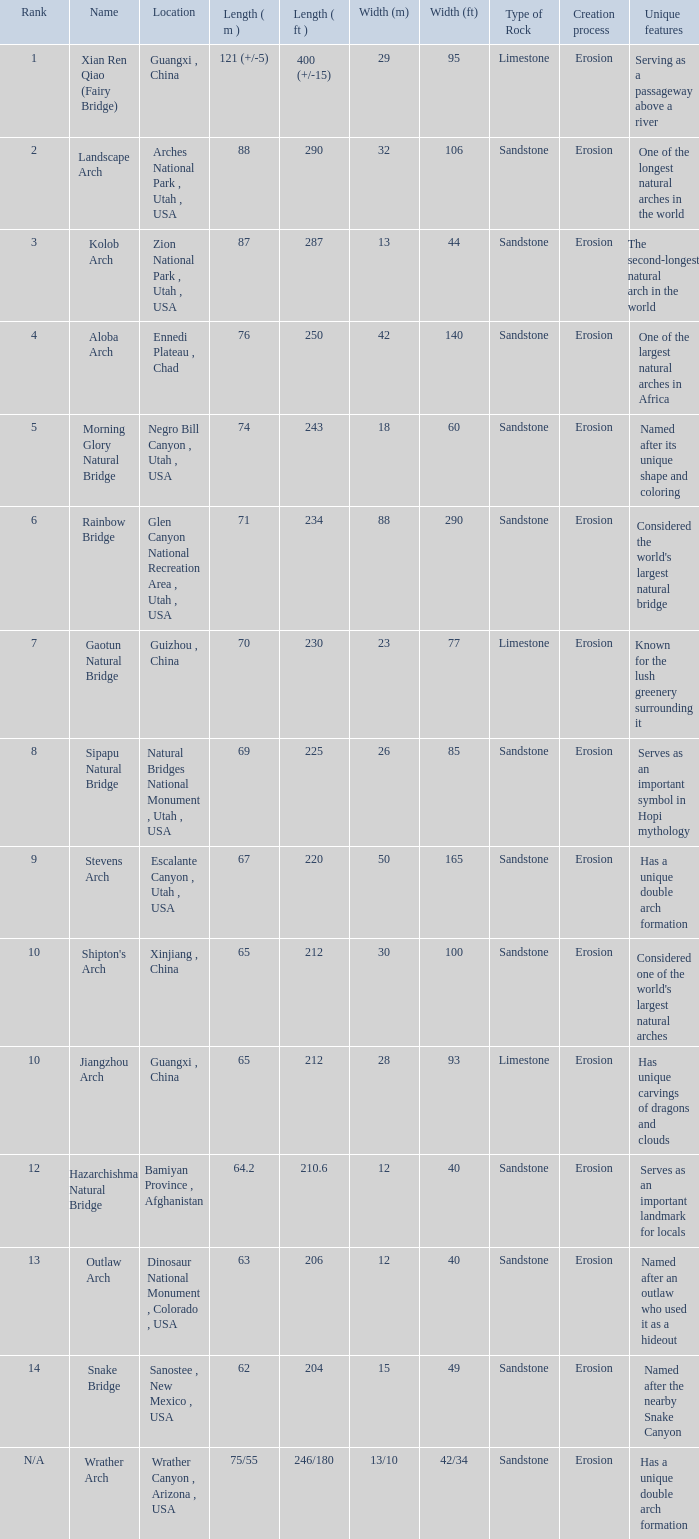Where is the longest arch with a length in meters of 64.2? Bamiyan Province , Afghanistan. 